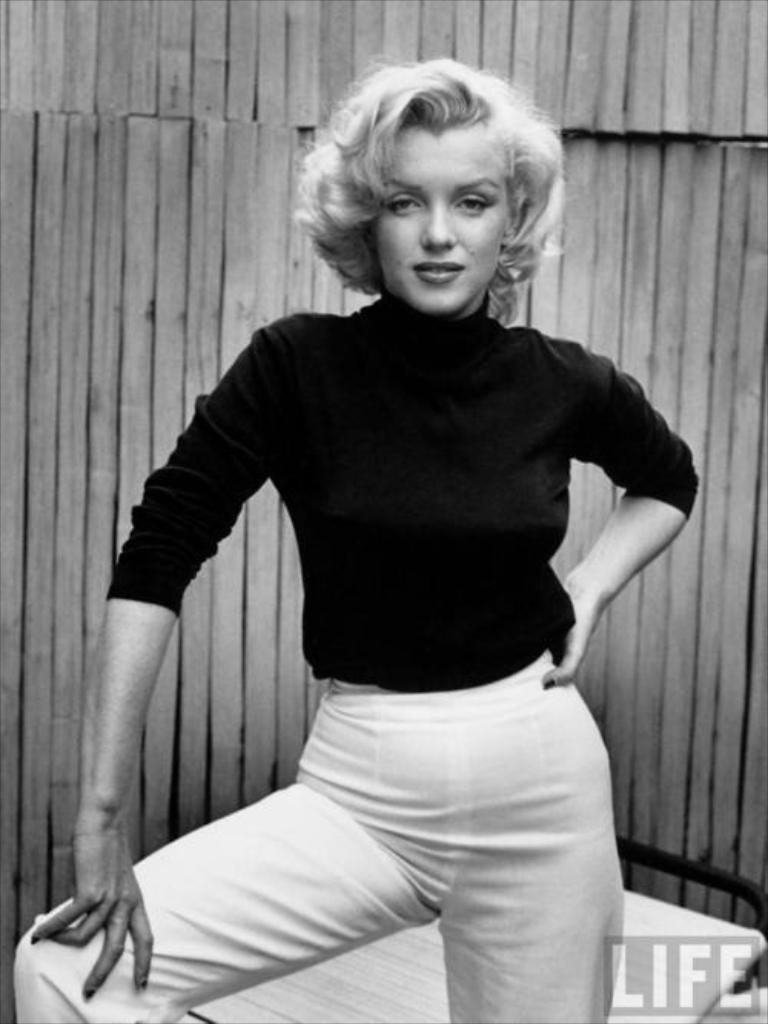In one or two sentences, can you explain what this image depicts? This is black and white image in this image there is a woman, in the background there is a wooden wall, in the bottom left there is text. 